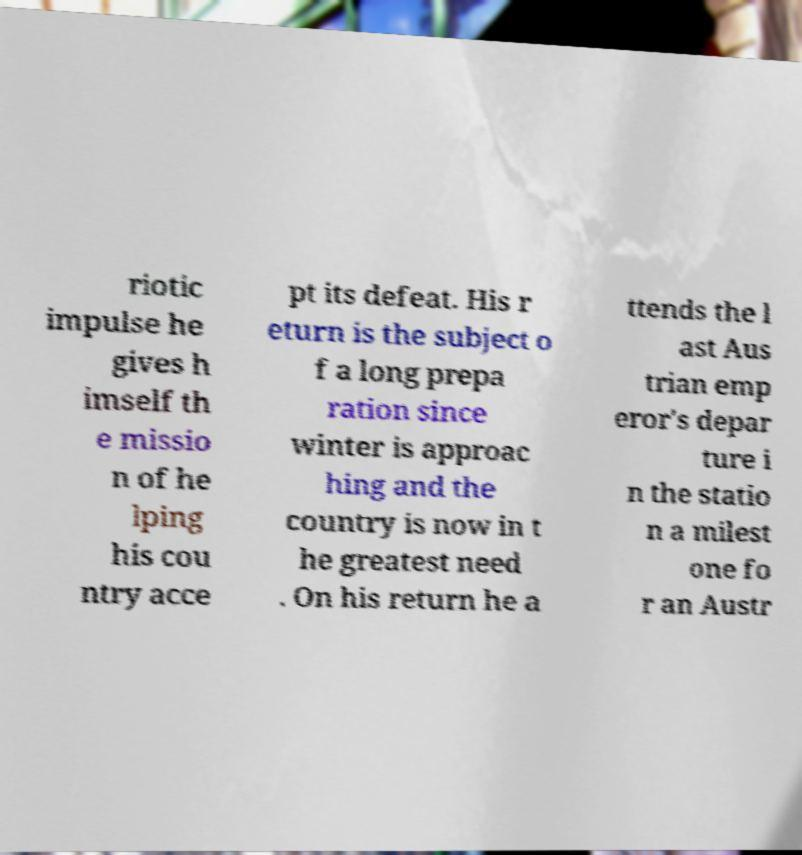Could you extract and type out the text from this image? riotic impulse he gives h imself th e missio n of he lping his cou ntry acce pt its defeat. His r eturn is the subject o f a long prepa ration since winter is approac hing and the country is now in t he greatest need . On his return he a ttends the l ast Aus trian emp eror's depar ture i n the statio n a milest one fo r an Austr 